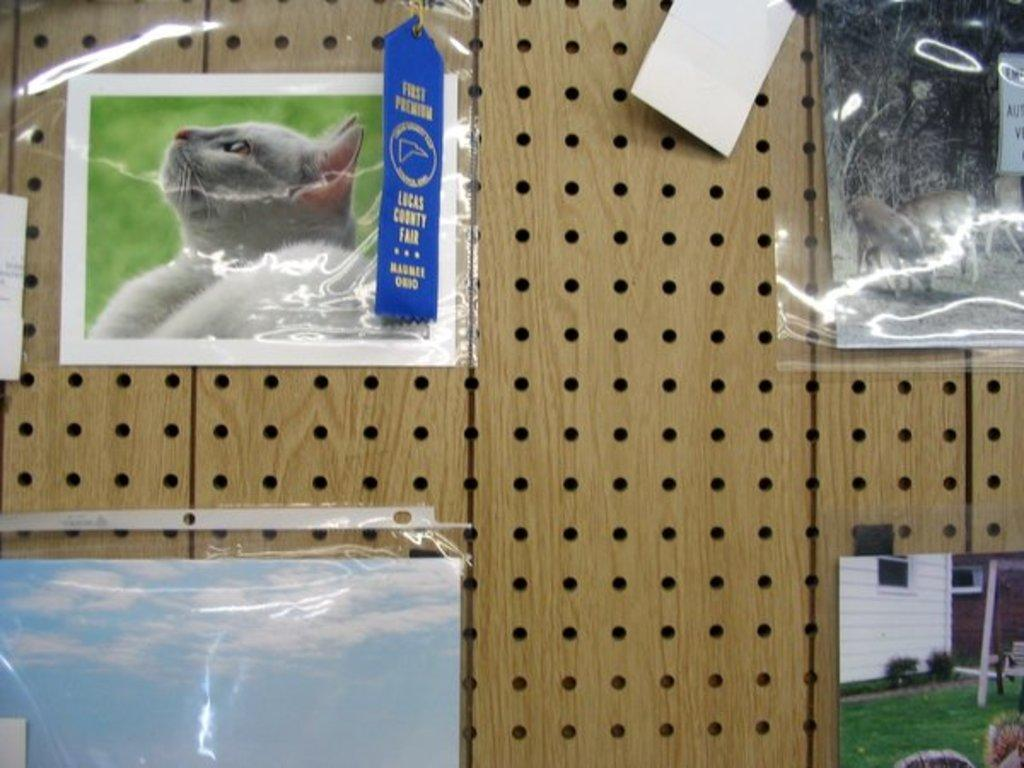What type of wall is visible in the image? There is a wooden wall in the image. Are there any unique features on the wooden wall? Yes, the wooden wall has holes. What is hung on the wooden wall? There are pictures on the wooden wall. How are the pictures protected or displayed? The pictures are kept in covers, which are stuck to the wall. How many mice can be seen running on the stove in the image? There is no stove or mice present in the image. 